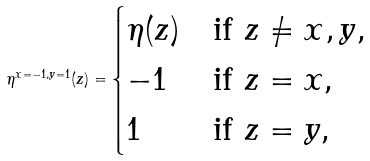<formula> <loc_0><loc_0><loc_500><loc_500>\eta ^ { x = - 1 , y = 1 } ( z ) = \begin{cases} \eta ( z ) & \text {if $z \neq x,y$,} \\ - 1 & \text {if $z=x$,} \\ 1 & \text {if $z=y$,} \end{cases}</formula> 